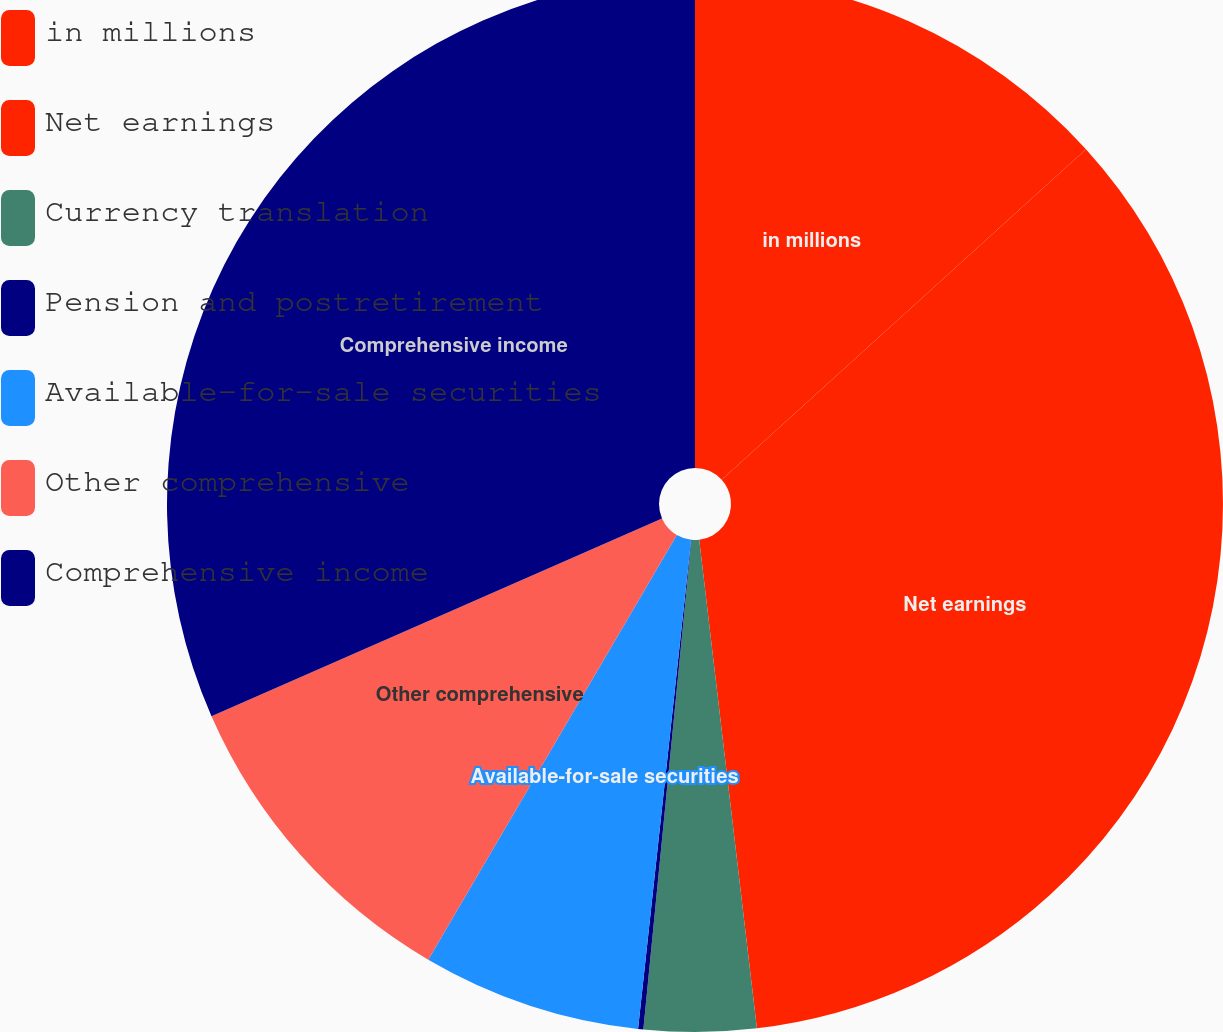<chart> <loc_0><loc_0><loc_500><loc_500><pie_chart><fcel>in millions<fcel>Net earnings<fcel>Currency translation<fcel>Pension and postretirement<fcel>Available-for-sale securities<fcel>Other comprehensive<fcel>Comprehensive income<nl><fcel>13.27%<fcel>34.86%<fcel>3.43%<fcel>0.16%<fcel>6.71%<fcel>9.99%<fcel>31.58%<nl></chart> 